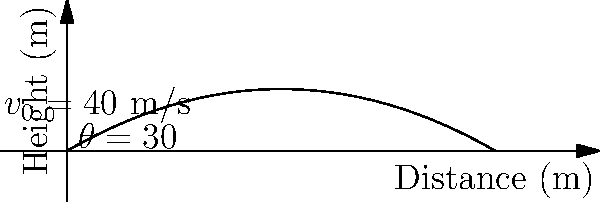Your son's baseball coach wants to analyze the trajectory of a pitched ball. If a baseball is thrown with an initial velocity of 40 m/s at an angle of 30° above the horizontal, what is the maximum height reached by the ball? Round your answer to the nearest tenth of a meter. To find the maximum height of the baseball, we'll follow these steps:

1) The vertical component of the initial velocity is given by:
   $v_{0y} = v_0 \sin(\theta) = 40 \sin(30°) = 20$ m/s

2) The time to reach the maximum height is when the vertical velocity becomes zero:
   $t_{max} = \frac{v_{0y}}{g}$, where $g = 9.8$ m/s²
   $t_{max} = \frac{20}{9.8} = 2.04$ seconds

3) The maximum height can be calculated using the equation:
   $h_{max} = v_{0y}t - \frac{1}{2}gt^2$

4) Substituting the values:
   $h_{max} = 20 * 2.04 - \frac{1}{2} * 9.8 * (2.04)^2$
   $h_{max} = 40.8 - 20.4 = 20.4$ meters

5) Rounding to the nearest tenth:
   $h_{max} \approx 20.4$ meters
Answer: 20.4 m 